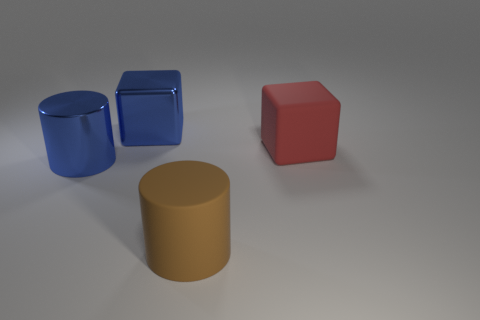Subtract all blue blocks. How many blocks are left? 1 Add 2 large cylinders. How many objects exist? 6 Subtract 0 purple blocks. How many objects are left? 4 Subtract 1 cubes. How many cubes are left? 1 Subtract all red blocks. Subtract all gray spheres. How many blocks are left? 1 Subtract all brown balls. How many red cubes are left? 1 Subtract all big rubber cubes. Subtract all big brown cylinders. How many objects are left? 2 Add 2 big blue metallic cylinders. How many big blue metallic cylinders are left? 3 Add 2 brown rubber objects. How many brown rubber objects exist? 3 